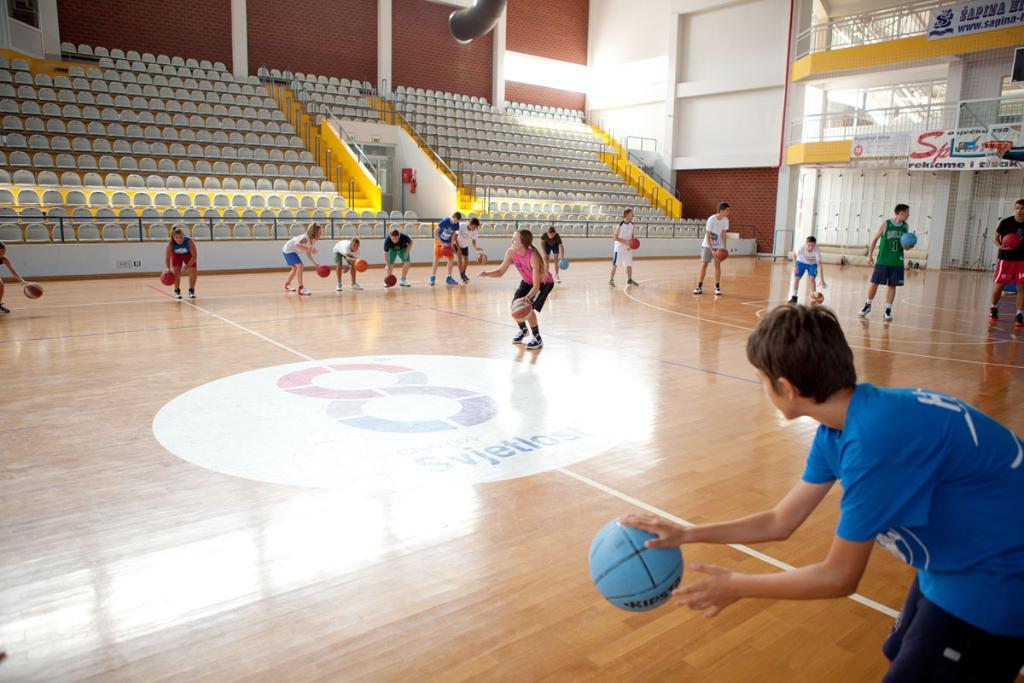<image>
Give a short and clear explanation of the subsequent image. Youth dribbling basketballs on a court with Svjetlost logo at center court 